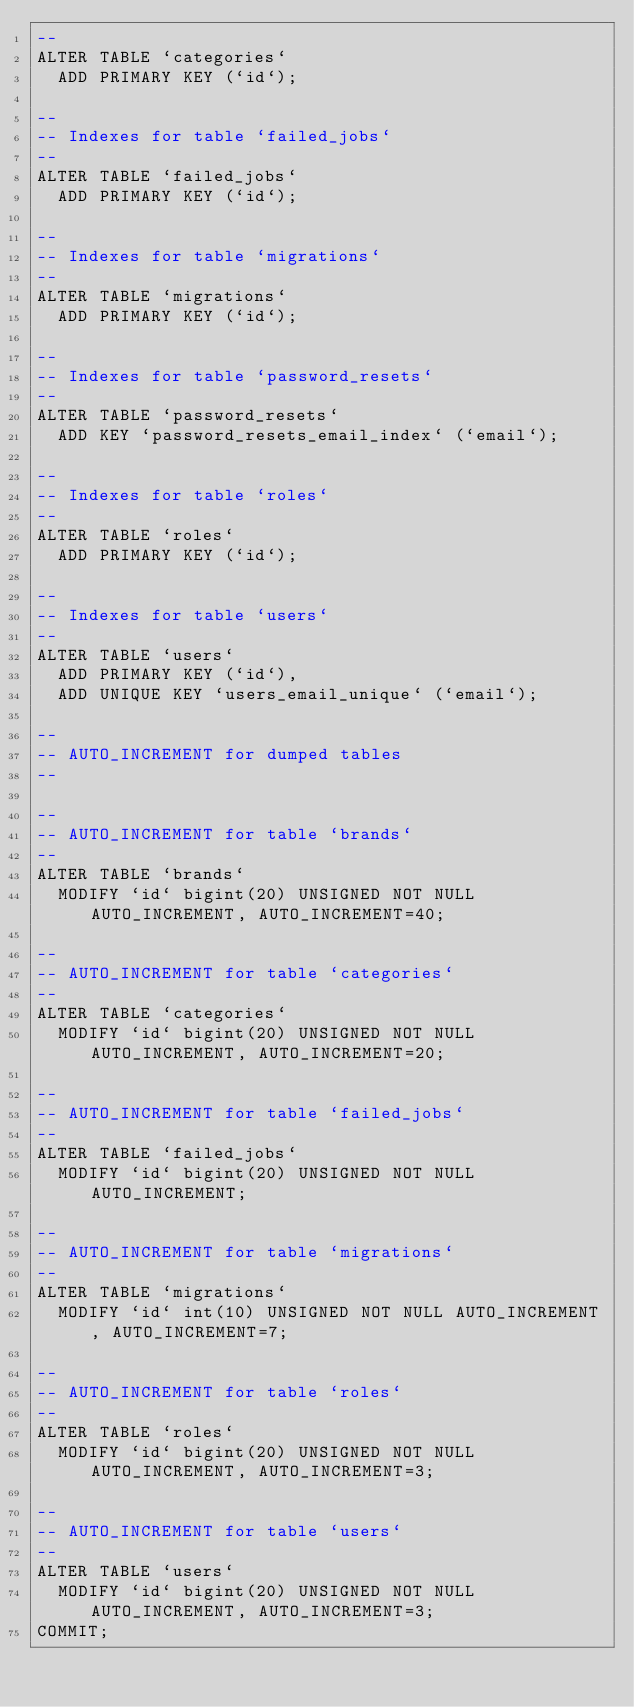Convert code to text. <code><loc_0><loc_0><loc_500><loc_500><_SQL_>--
ALTER TABLE `categories`
  ADD PRIMARY KEY (`id`);

--
-- Indexes for table `failed_jobs`
--
ALTER TABLE `failed_jobs`
  ADD PRIMARY KEY (`id`);

--
-- Indexes for table `migrations`
--
ALTER TABLE `migrations`
  ADD PRIMARY KEY (`id`);

--
-- Indexes for table `password_resets`
--
ALTER TABLE `password_resets`
  ADD KEY `password_resets_email_index` (`email`);

--
-- Indexes for table `roles`
--
ALTER TABLE `roles`
  ADD PRIMARY KEY (`id`);

--
-- Indexes for table `users`
--
ALTER TABLE `users`
  ADD PRIMARY KEY (`id`),
  ADD UNIQUE KEY `users_email_unique` (`email`);

--
-- AUTO_INCREMENT for dumped tables
--

--
-- AUTO_INCREMENT for table `brands`
--
ALTER TABLE `brands`
  MODIFY `id` bigint(20) UNSIGNED NOT NULL AUTO_INCREMENT, AUTO_INCREMENT=40;

--
-- AUTO_INCREMENT for table `categories`
--
ALTER TABLE `categories`
  MODIFY `id` bigint(20) UNSIGNED NOT NULL AUTO_INCREMENT, AUTO_INCREMENT=20;

--
-- AUTO_INCREMENT for table `failed_jobs`
--
ALTER TABLE `failed_jobs`
  MODIFY `id` bigint(20) UNSIGNED NOT NULL AUTO_INCREMENT;

--
-- AUTO_INCREMENT for table `migrations`
--
ALTER TABLE `migrations`
  MODIFY `id` int(10) UNSIGNED NOT NULL AUTO_INCREMENT, AUTO_INCREMENT=7;

--
-- AUTO_INCREMENT for table `roles`
--
ALTER TABLE `roles`
  MODIFY `id` bigint(20) UNSIGNED NOT NULL AUTO_INCREMENT, AUTO_INCREMENT=3;

--
-- AUTO_INCREMENT for table `users`
--
ALTER TABLE `users`
  MODIFY `id` bigint(20) UNSIGNED NOT NULL AUTO_INCREMENT, AUTO_INCREMENT=3;
COMMIT;
</code> 